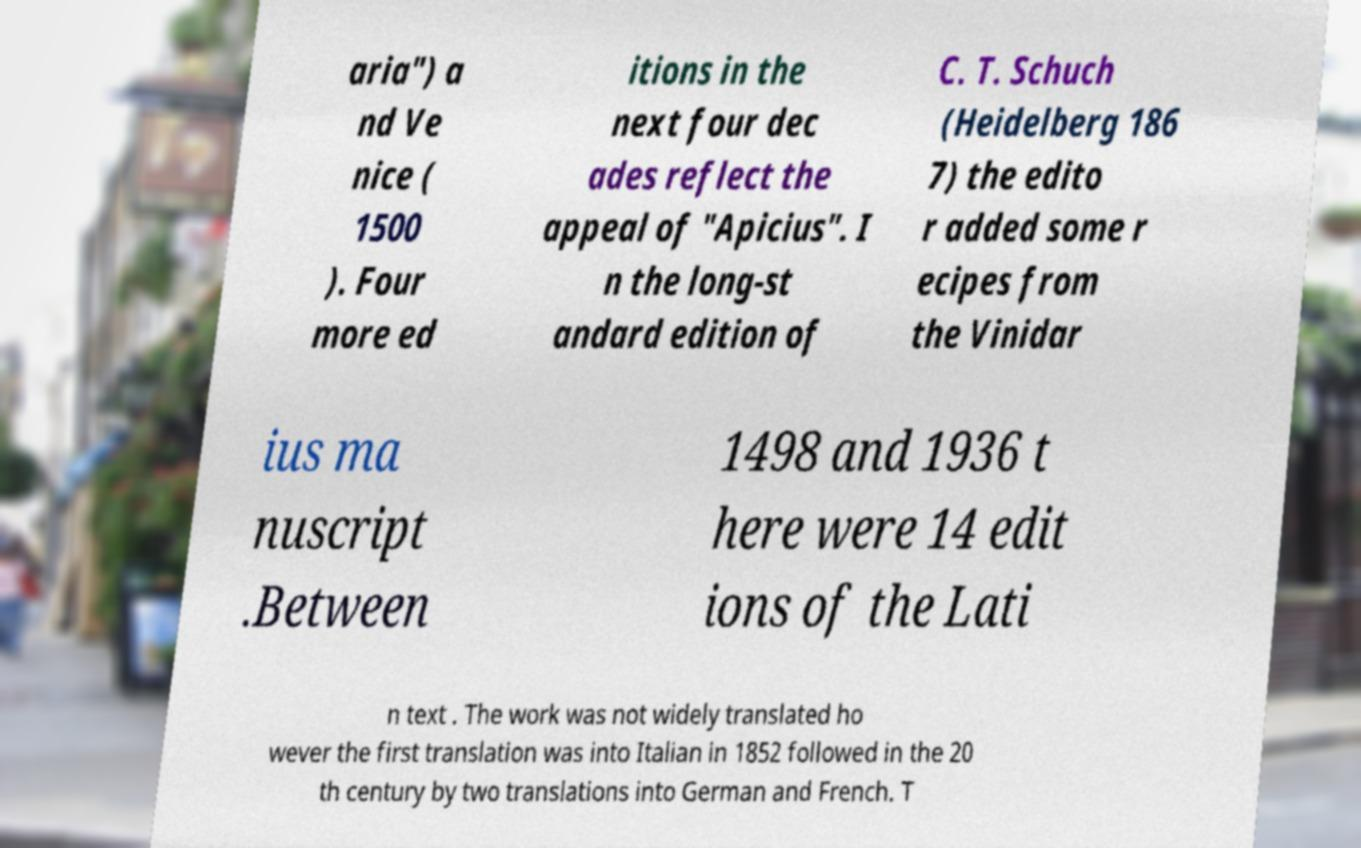There's text embedded in this image that I need extracted. Can you transcribe it verbatim? aria") a nd Ve nice ( 1500 ). Four more ed itions in the next four dec ades reflect the appeal of "Apicius". I n the long-st andard edition of C. T. Schuch (Heidelberg 186 7) the edito r added some r ecipes from the Vinidar ius ma nuscript .Between 1498 and 1936 t here were 14 edit ions of the Lati n text . The work was not widely translated ho wever the first translation was into Italian in 1852 followed in the 20 th century by two translations into German and French. T 